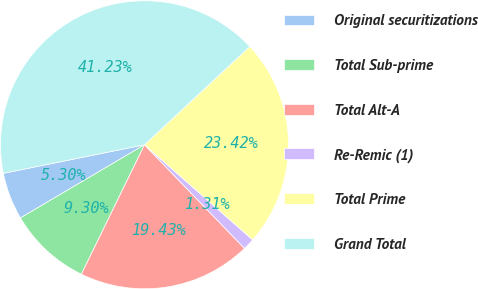<chart> <loc_0><loc_0><loc_500><loc_500><pie_chart><fcel>Original securitizations<fcel>Total Sub-prime<fcel>Total Alt-A<fcel>Re-Remic (1)<fcel>Total Prime<fcel>Grand Total<nl><fcel>5.3%<fcel>9.3%<fcel>19.43%<fcel>1.31%<fcel>23.42%<fcel>41.23%<nl></chart> 